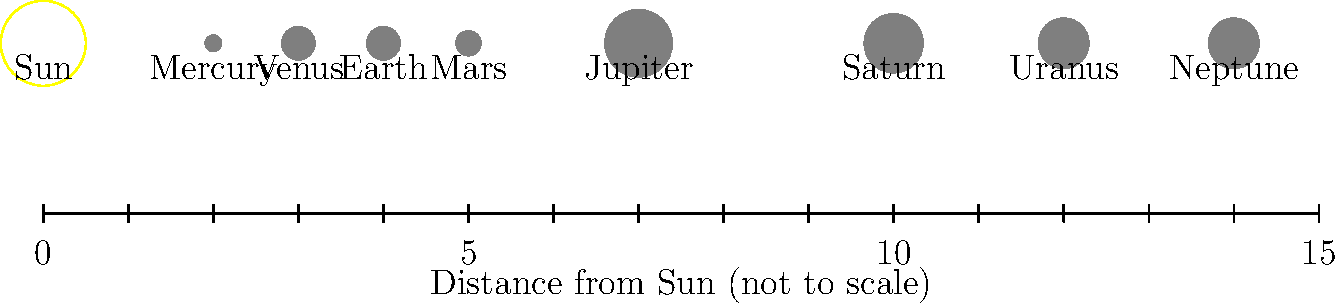Based on your experience with property registration systems, which can involve understanding relative distances and sizes, examine the diagram of our solar system. Which planet is represented as the largest, and approximately how many times farther from the Sun is it compared to Earth? To answer this question, we need to analyze the diagram and follow these steps:

1. Identify the largest planet:
   Looking at the sizes of the planets in the diagram, we can see that Jupiter is represented as the largest planet.

2. Locate Earth and Jupiter:
   Earth is the third planet from the Sun, and Jupiter is the fifth.

3. Determine their distances from the Sun:
   Using the scale at the bottom of the diagram:
   - Earth is positioned at approximately 4 units from the Sun
   - Jupiter is positioned at approximately 7 units from the Sun

4. Calculate the relative distance:
   To find how many times farther Jupiter is from the Sun compared to Earth, we divide Jupiter's distance by Earth's distance:

   $\frac{\text{Jupiter's distance}}{\text{Earth's distance}} = \frac{7}{4} = 1.75$

Therefore, according to this simplified diagram, Jupiter is represented as the largest planet and is approximately 1.75 times farther from the Sun than Earth.

Note: This diagram is not to scale, and in reality, Jupiter is about 5.2 times farther from the Sun than Earth. The diagram is a simplified representation to show the order of planets and their relative sizes.
Answer: Jupiter; 1.75 times 